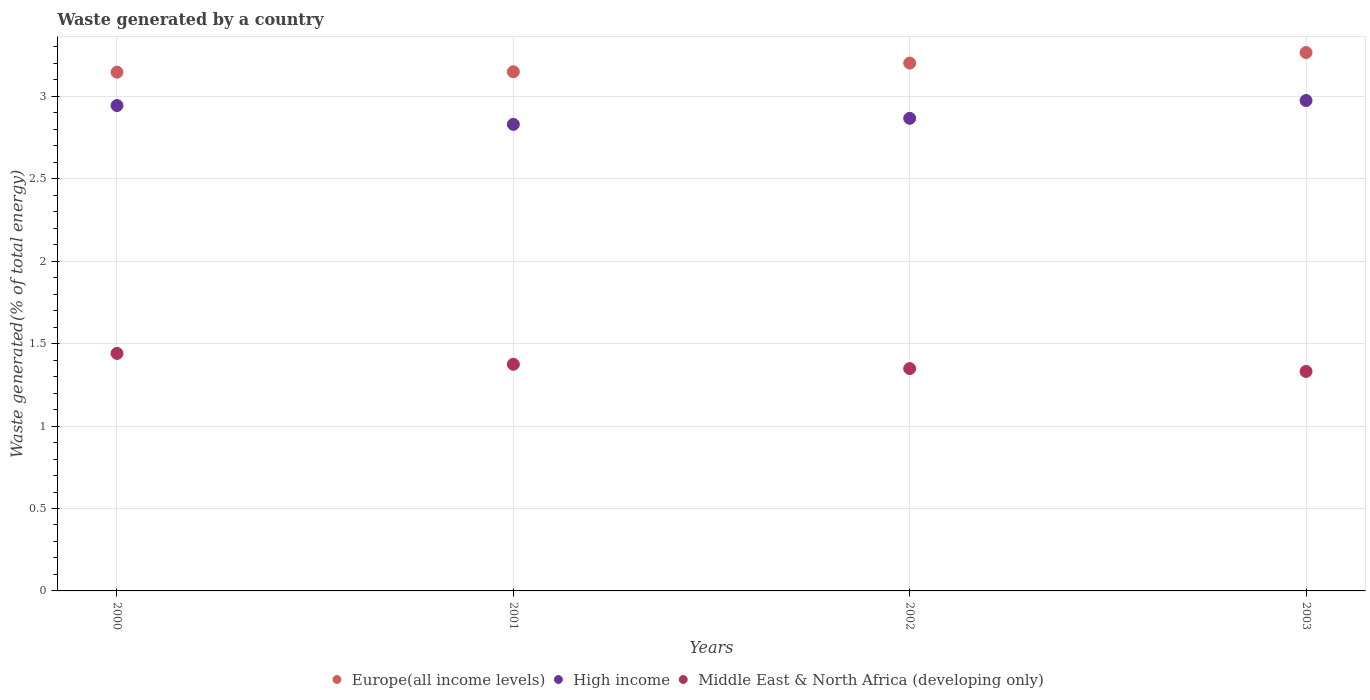How many different coloured dotlines are there?
Keep it short and to the point. 3. Is the number of dotlines equal to the number of legend labels?
Your response must be concise. Yes. What is the total waste generated in Europe(all income levels) in 2002?
Make the answer very short. 3.2. Across all years, what is the maximum total waste generated in Middle East & North Africa (developing only)?
Your answer should be compact. 1.44. Across all years, what is the minimum total waste generated in High income?
Keep it short and to the point. 2.83. In which year was the total waste generated in Europe(all income levels) maximum?
Offer a very short reply. 2003. What is the total total waste generated in Middle East & North Africa (developing only) in the graph?
Provide a short and direct response. 5.5. What is the difference between the total waste generated in High income in 2001 and that in 2002?
Make the answer very short. -0.04. What is the difference between the total waste generated in High income in 2001 and the total waste generated in Middle East & North Africa (developing only) in 2000?
Offer a very short reply. 1.39. What is the average total waste generated in High income per year?
Provide a succinct answer. 2.9. In the year 2003, what is the difference between the total waste generated in High income and total waste generated in Europe(all income levels)?
Offer a terse response. -0.29. What is the ratio of the total waste generated in Europe(all income levels) in 2001 to that in 2002?
Provide a short and direct response. 0.98. What is the difference between the highest and the second highest total waste generated in High income?
Ensure brevity in your answer.  0.03. What is the difference between the highest and the lowest total waste generated in Middle East & North Africa (developing only)?
Your response must be concise. 0.11. In how many years, is the total waste generated in High income greater than the average total waste generated in High income taken over all years?
Your answer should be very brief. 2. Is it the case that in every year, the sum of the total waste generated in Europe(all income levels) and total waste generated in High income  is greater than the total waste generated in Middle East & North Africa (developing only)?
Offer a terse response. Yes. Does the total waste generated in High income monotonically increase over the years?
Your answer should be very brief. No. Is the total waste generated in Europe(all income levels) strictly greater than the total waste generated in Middle East & North Africa (developing only) over the years?
Make the answer very short. Yes. Does the graph contain grids?
Ensure brevity in your answer.  Yes. How are the legend labels stacked?
Provide a succinct answer. Horizontal. What is the title of the graph?
Your answer should be compact. Waste generated by a country. Does "Kuwait" appear as one of the legend labels in the graph?
Offer a terse response. No. What is the label or title of the Y-axis?
Your answer should be very brief. Waste generated(% of total energy). What is the Waste generated(% of total energy) in Europe(all income levels) in 2000?
Make the answer very short. 3.15. What is the Waste generated(% of total energy) in High income in 2000?
Offer a terse response. 2.94. What is the Waste generated(% of total energy) of Middle East & North Africa (developing only) in 2000?
Give a very brief answer. 1.44. What is the Waste generated(% of total energy) of Europe(all income levels) in 2001?
Give a very brief answer. 3.15. What is the Waste generated(% of total energy) in High income in 2001?
Ensure brevity in your answer.  2.83. What is the Waste generated(% of total energy) in Middle East & North Africa (developing only) in 2001?
Offer a terse response. 1.37. What is the Waste generated(% of total energy) in Europe(all income levels) in 2002?
Provide a succinct answer. 3.2. What is the Waste generated(% of total energy) of High income in 2002?
Provide a short and direct response. 2.87. What is the Waste generated(% of total energy) of Middle East & North Africa (developing only) in 2002?
Offer a terse response. 1.35. What is the Waste generated(% of total energy) of Europe(all income levels) in 2003?
Ensure brevity in your answer.  3.27. What is the Waste generated(% of total energy) of High income in 2003?
Your answer should be very brief. 2.98. What is the Waste generated(% of total energy) in Middle East & North Africa (developing only) in 2003?
Your answer should be compact. 1.33. Across all years, what is the maximum Waste generated(% of total energy) of Europe(all income levels)?
Your answer should be very brief. 3.27. Across all years, what is the maximum Waste generated(% of total energy) in High income?
Your answer should be very brief. 2.98. Across all years, what is the maximum Waste generated(% of total energy) in Middle East & North Africa (developing only)?
Your answer should be very brief. 1.44. Across all years, what is the minimum Waste generated(% of total energy) in Europe(all income levels)?
Your response must be concise. 3.15. Across all years, what is the minimum Waste generated(% of total energy) in High income?
Make the answer very short. 2.83. Across all years, what is the minimum Waste generated(% of total energy) of Middle East & North Africa (developing only)?
Give a very brief answer. 1.33. What is the total Waste generated(% of total energy) of Europe(all income levels) in the graph?
Your response must be concise. 12.77. What is the total Waste generated(% of total energy) of High income in the graph?
Give a very brief answer. 11.62. What is the total Waste generated(% of total energy) in Middle East & North Africa (developing only) in the graph?
Ensure brevity in your answer.  5.5. What is the difference between the Waste generated(% of total energy) of Europe(all income levels) in 2000 and that in 2001?
Your answer should be very brief. -0. What is the difference between the Waste generated(% of total energy) of High income in 2000 and that in 2001?
Your response must be concise. 0.11. What is the difference between the Waste generated(% of total energy) of Middle East & North Africa (developing only) in 2000 and that in 2001?
Keep it short and to the point. 0.07. What is the difference between the Waste generated(% of total energy) in Europe(all income levels) in 2000 and that in 2002?
Your answer should be compact. -0.06. What is the difference between the Waste generated(% of total energy) of High income in 2000 and that in 2002?
Provide a succinct answer. 0.08. What is the difference between the Waste generated(% of total energy) in Middle East & North Africa (developing only) in 2000 and that in 2002?
Offer a very short reply. 0.09. What is the difference between the Waste generated(% of total energy) of Europe(all income levels) in 2000 and that in 2003?
Make the answer very short. -0.12. What is the difference between the Waste generated(% of total energy) of High income in 2000 and that in 2003?
Offer a terse response. -0.03. What is the difference between the Waste generated(% of total energy) of Middle East & North Africa (developing only) in 2000 and that in 2003?
Give a very brief answer. 0.11. What is the difference between the Waste generated(% of total energy) of Europe(all income levels) in 2001 and that in 2002?
Give a very brief answer. -0.05. What is the difference between the Waste generated(% of total energy) of High income in 2001 and that in 2002?
Your response must be concise. -0.04. What is the difference between the Waste generated(% of total energy) in Middle East & North Africa (developing only) in 2001 and that in 2002?
Your answer should be compact. 0.03. What is the difference between the Waste generated(% of total energy) of Europe(all income levels) in 2001 and that in 2003?
Keep it short and to the point. -0.12. What is the difference between the Waste generated(% of total energy) in High income in 2001 and that in 2003?
Keep it short and to the point. -0.14. What is the difference between the Waste generated(% of total energy) of Middle East & North Africa (developing only) in 2001 and that in 2003?
Provide a succinct answer. 0.04. What is the difference between the Waste generated(% of total energy) of Europe(all income levels) in 2002 and that in 2003?
Offer a very short reply. -0.06. What is the difference between the Waste generated(% of total energy) in High income in 2002 and that in 2003?
Give a very brief answer. -0.11. What is the difference between the Waste generated(% of total energy) in Middle East & North Africa (developing only) in 2002 and that in 2003?
Offer a very short reply. 0.02. What is the difference between the Waste generated(% of total energy) in Europe(all income levels) in 2000 and the Waste generated(% of total energy) in High income in 2001?
Offer a terse response. 0.32. What is the difference between the Waste generated(% of total energy) in Europe(all income levels) in 2000 and the Waste generated(% of total energy) in Middle East & North Africa (developing only) in 2001?
Make the answer very short. 1.77. What is the difference between the Waste generated(% of total energy) of High income in 2000 and the Waste generated(% of total energy) of Middle East & North Africa (developing only) in 2001?
Ensure brevity in your answer.  1.57. What is the difference between the Waste generated(% of total energy) of Europe(all income levels) in 2000 and the Waste generated(% of total energy) of High income in 2002?
Your answer should be compact. 0.28. What is the difference between the Waste generated(% of total energy) in Europe(all income levels) in 2000 and the Waste generated(% of total energy) in Middle East & North Africa (developing only) in 2002?
Provide a succinct answer. 1.8. What is the difference between the Waste generated(% of total energy) of High income in 2000 and the Waste generated(% of total energy) of Middle East & North Africa (developing only) in 2002?
Your answer should be compact. 1.6. What is the difference between the Waste generated(% of total energy) of Europe(all income levels) in 2000 and the Waste generated(% of total energy) of High income in 2003?
Ensure brevity in your answer.  0.17. What is the difference between the Waste generated(% of total energy) in Europe(all income levels) in 2000 and the Waste generated(% of total energy) in Middle East & North Africa (developing only) in 2003?
Give a very brief answer. 1.82. What is the difference between the Waste generated(% of total energy) of High income in 2000 and the Waste generated(% of total energy) of Middle East & North Africa (developing only) in 2003?
Make the answer very short. 1.61. What is the difference between the Waste generated(% of total energy) in Europe(all income levels) in 2001 and the Waste generated(% of total energy) in High income in 2002?
Provide a short and direct response. 0.28. What is the difference between the Waste generated(% of total energy) in Europe(all income levels) in 2001 and the Waste generated(% of total energy) in Middle East & North Africa (developing only) in 2002?
Offer a terse response. 1.8. What is the difference between the Waste generated(% of total energy) of High income in 2001 and the Waste generated(% of total energy) of Middle East & North Africa (developing only) in 2002?
Provide a succinct answer. 1.48. What is the difference between the Waste generated(% of total energy) of Europe(all income levels) in 2001 and the Waste generated(% of total energy) of High income in 2003?
Provide a short and direct response. 0.17. What is the difference between the Waste generated(% of total energy) of Europe(all income levels) in 2001 and the Waste generated(% of total energy) of Middle East & North Africa (developing only) in 2003?
Offer a very short reply. 1.82. What is the difference between the Waste generated(% of total energy) in High income in 2001 and the Waste generated(% of total energy) in Middle East & North Africa (developing only) in 2003?
Your answer should be very brief. 1.5. What is the difference between the Waste generated(% of total energy) in Europe(all income levels) in 2002 and the Waste generated(% of total energy) in High income in 2003?
Offer a terse response. 0.23. What is the difference between the Waste generated(% of total energy) in Europe(all income levels) in 2002 and the Waste generated(% of total energy) in Middle East & North Africa (developing only) in 2003?
Make the answer very short. 1.87. What is the difference between the Waste generated(% of total energy) of High income in 2002 and the Waste generated(% of total energy) of Middle East & North Africa (developing only) in 2003?
Keep it short and to the point. 1.54. What is the average Waste generated(% of total energy) in Europe(all income levels) per year?
Keep it short and to the point. 3.19. What is the average Waste generated(% of total energy) in High income per year?
Ensure brevity in your answer.  2.9. What is the average Waste generated(% of total energy) of Middle East & North Africa (developing only) per year?
Give a very brief answer. 1.37. In the year 2000, what is the difference between the Waste generated(% of total energy) of Europe(all income levels) and Waste generated(% of total energy) of High income?
Ensure brevity in your answer.  0.2. In the year 2000, what is the difference between the Waste generated(% of total energy) of Europe(all income levels) and Waste generated(% of total energy) of Middle East & North Africa (developing only)?
Your answer should be compact. 1.71. In the year 2000, what is the difference between the Waste generated(% of total energy) in High income and Waste generated(% of total energy) in Middle East & North Africa (developing only)?
Your answer should be very brief. 1.5. In the year 2001, what is the difference between the Waste generated(% of total energy) in Europe(all income levels) and Waste generated(% of total energy) in High income?
Give a very brief answer. 0.32. In the year 2001, what is the difference between the Waste generated(% of total energy) of Europe(all income levels) and Waste generated(% of total energy) of Middle East & North Africa (developing only)?
Your answer should be very brief. 1.77. In the year 2001, what is the difference between the Waste generated(% of total energy) in High income and Waste generated(% of total energy) in Middle East & North Africa (developing only)?
Your answer should be compact. 1.46. In the year 2002, what is the difference between the Waste generated(% of total energy) in Europe(all income levels) and Waste generated(% of total energy) in High income?
Your answer should be very brief. 0.34. In the year 2002, what is the difference between the Waste generated(% of total energy) of Europe(all income levels) and Waste generated(% of total energy) of Middle East & North Africa (developing only)?
Offer a terse response. 1.85. In the year 2002, what is the difference between the Waste generated(% of total energy) of High income and Waste generated(% of total energy) of Middle East & North Africa (developing only)?
Your response must be concise. 1.52. In the year 2003, what is the difference between the Waste generated(% of total energy) in Europe(all income levels) and Waste generated(% of total energy) in High income?
Your answer should be very brief. 0.29. In the year 2003, what is the difference between the Waste generated(% of total energy) of Europe(all income levels) and Waste generated(% of total energy) of Middle East & North Africa (developing only)?
Give a very brief answer. 1.94. In the year 2003, what is the difference between the Waste generated(% of total energy) of High income and Waste generated(% of total energy) of Middle East & North Africa (developing only)?
Give a very brief answer. 1.64. What is the ratio of the Waste generated(% of total energy) of Europe(all income levels) in 2000 to that in 2001?
Your answer should be very brief. 1. What is the ratio of the Waste generated(% of total energy) of High income in 2000 to that in 2001?
Make the answer very short. 1.04. What is the ratio of the Waste generated(% of total energy) of Middle East & North Africa (developing only) in 2000 to that in 2001?
Keep it short and to the point. 1.05. What is the ratio of the Waste generated(% of total energy) of Europe(all income levels) in 2000 to that in 2002?
Make the answer very short. 0.98. What is the ratio of the Waste generated(% of total energy) in High income in 2000 to that in 2002?
Make the answer very short. 1.03. What is the ratio of the Waste generated(% of total energy) in Middle East & North Africa (developing only) in 2000 to that in 2002?
Offer a very short reply. 1.07. What is the ratio of the Waste generated(% of total energy) of Europe(all income levels) in 2000 to that in 2003?
Provide a short and direct response. 0.96. What is the ratio of the Waste generated(% of total energy) of High income in 2000 to that in 2003?
Make the answer very short. 0.99. What is the ratio of the Waste generated(% of total energy) of Middle East & North Africa (developing only) in 2000 to that in 2003?
Give a very brief answer. 1.08. What is the ratio of the Waste generated(% of total energy) of Europe(all income levels) in 2001 to that in 2002?
Provide a succinct answer. 0.98. What is the ratio of the Waste generated(% of total energy) of High income in 2001 to that in 2002?
Keep it short and to the point. 0.99. What is the ratio of the Waste generated(% of total energy) in Middle East & North Africa (developing only) in 2001 to that in 2002?
Make the answer very short. 1.02. What is the ratio of the Waste generated(% of total energy) of Europe(all income levels) in 2001 to that in 2003?
Provide a succinct answer. 0.96. What is the ratio of the Waste generated(% of total energy) of High income in 2001 to that in 2003?
Offer a terse response. 0.95. What is the ratio of the Waste generated(% of total energy) of Middle East & North Africa (developing only) in 2001 to that in 2003?
Make the answer very short. 1.03. What is the ratio of the Waste generated(% of total energy) in Europe(all income levels) in 2002 to that in 2003?
Your answer should be very brief. 0.98. What is the ratio of the Waste generated(% of total energy) in High income in 2002 to that in 2003?
Keep it short and to the point. 0.96. What is the ratio of the Waste generated(% of total energy) in Middle East & North Africa (developing only) in 2002 to that in 2003?
Keep it short and to the point. 1.01. What is the difference between the highest and the second highest Waste generated(% of total energy) of Europe(all income levels)?
Your response must be concise. 0.06. What is the difference between the highest and the second highest Waste generated(% of total energy) in High income?
Ensure brevity in your answer.  0.03. What is the difference between the highest and the second highest Waste generated(% of total energy) in Middle East & North Africa (developing only)?
Your answer should be compact. 0.07. What is the difference between the highest and the lowest Waste generated(% of total energy) of Europe(all income levels)?
Keep it short and to the point. 0.12. What is the difference between the highest and the lowest Waste generated(% of total energy) in High income?
Your answer should be compact. 0.14. What is the difference between the highest and the lowest Waste generated(% of total energy) in Middle East & North Africa (developing only)?
Make the answer very short. 0.11. 